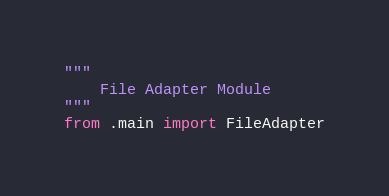Convert code to text. <code><loc_0><loc_0><loc_500><loc_500><_Python_>"""
    File Adapter Module
"""
from .main import FileAdapter
</code> 